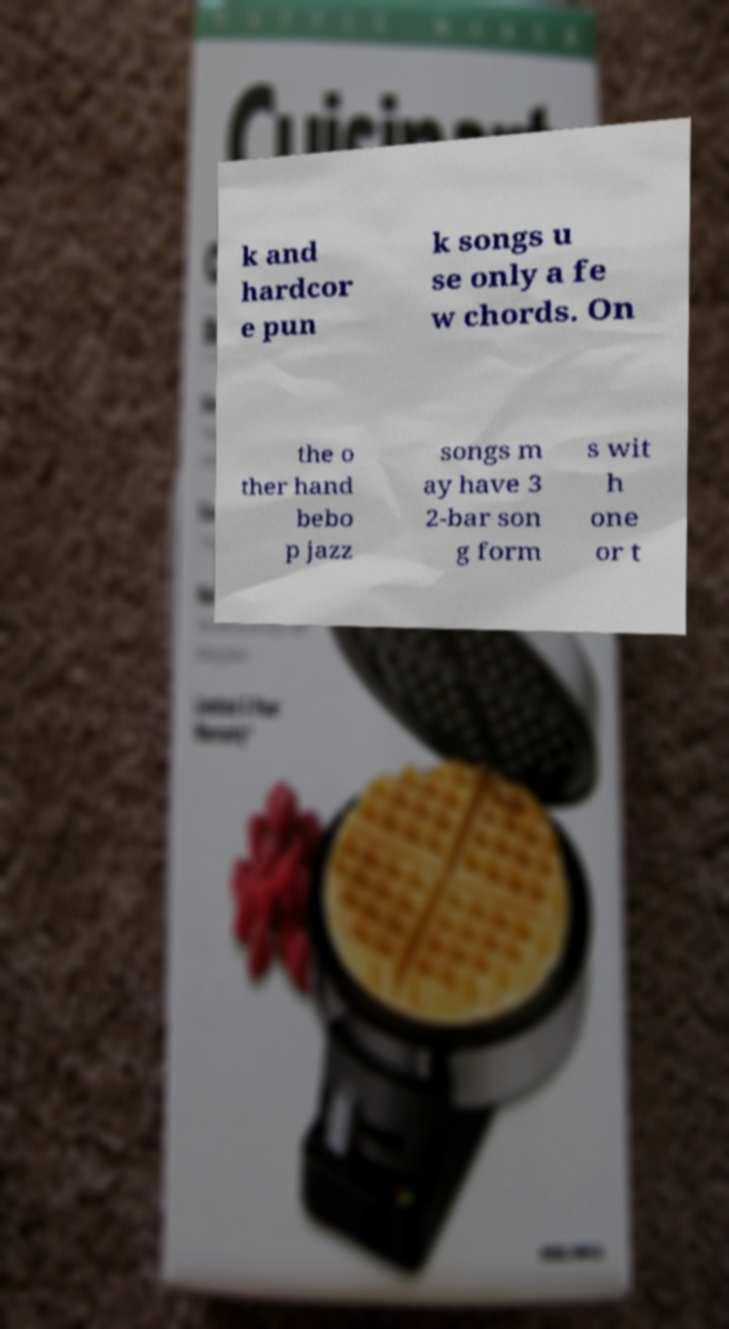For documentation purposes, I need the text within this image transcribed. Could you provide that? k and hardcor e pun k songs u se only a fe w chords. On the o ther hand bebo p jazz songs m ay have 3 2-bar son g form s wit h one or t 